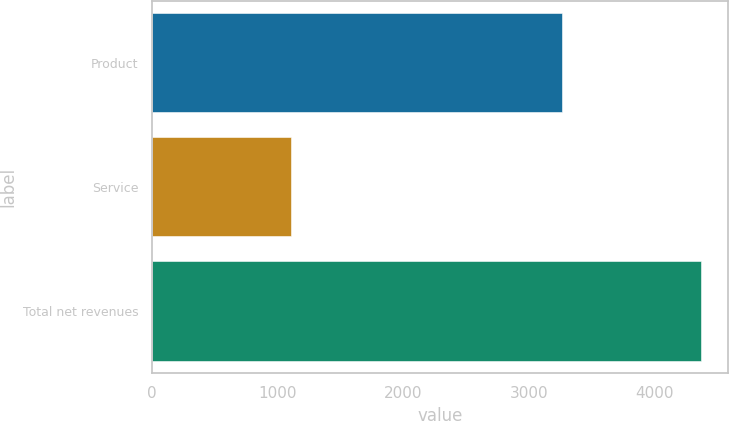<chart> <loc_0><loc_0><loc_500><loc_500><bar_chart><fcel>Product<fcel>Service<fcel>Total net revenues<nl><fcel>3262.1<fcel>1103.3<fcel>4365.4<nl></chart> 